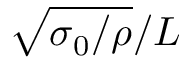Convert formula to latex. <formula><loc_0><loc_0><loc_500><loc_500>\sqrt { \sigma _ { 0 } / \rho } / L</formula> 